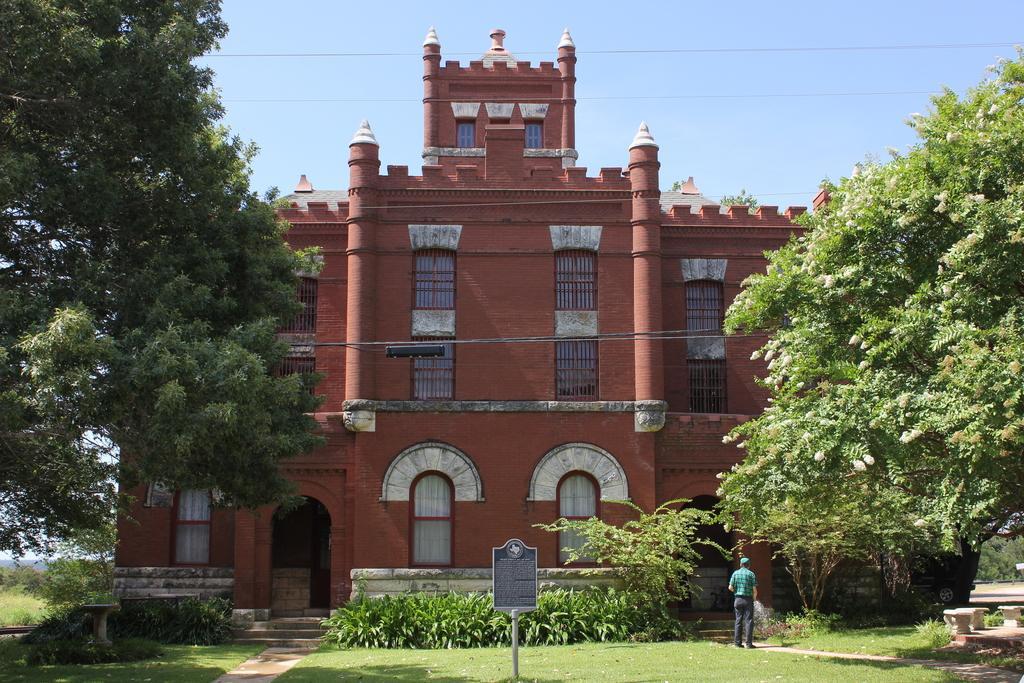In one or two sentences, can you explain what this image depicts? It is a big building and in front of the building there is a garden and beside the garden a person is standing and there is a board dug in the garden,around the building there are some trees. 